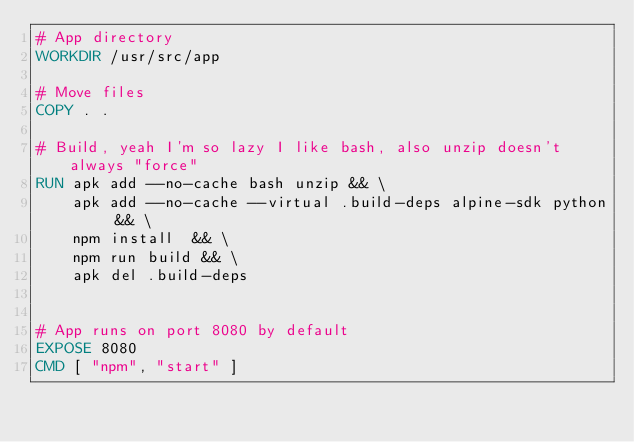<code> <loc_0><loc_0><loc_500><loc_500><_Dockerfile_># App directory
WORKDIR /usr/src/app

# Move files
COPY . .

# Build, yeah I'm so lazy I like bash, also unzip doesn't always "force"
RUN apk add --no-cache bash unzip && \
    apk add --no-cache --virtual .build-deps alpine-sdk python && \
    npm install  && \
    npm run build && \
    apk del .build-deps


# App runs on port 8080 by default
EXPOSE 8080
CMD [ "npm", "start" ]
</code> 